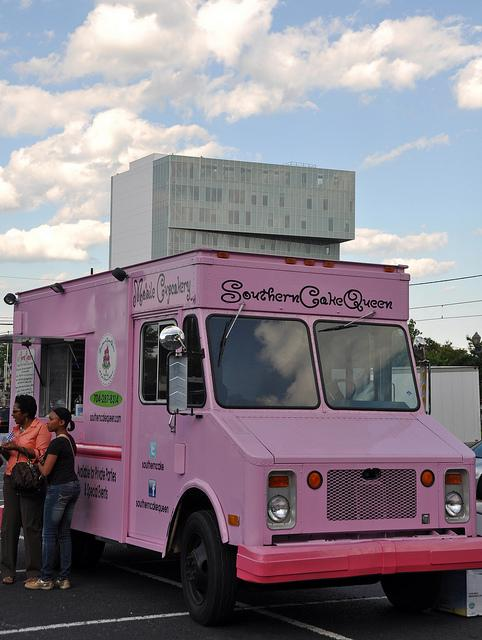If this truck sold food the same color that the truck is what food would it sell?

Choices:
A) blueberry
B) watermelon
C) peas
D) carrot watermelon 